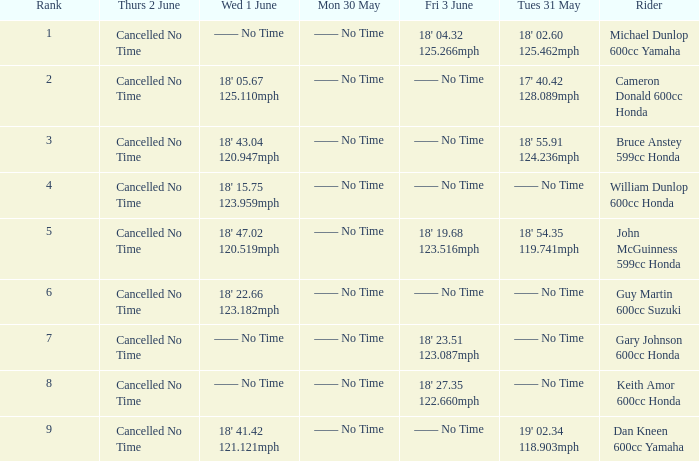What is the number of riders that had a Tues 31 May time of 18' 55.91 124.236mph? 1.0. 